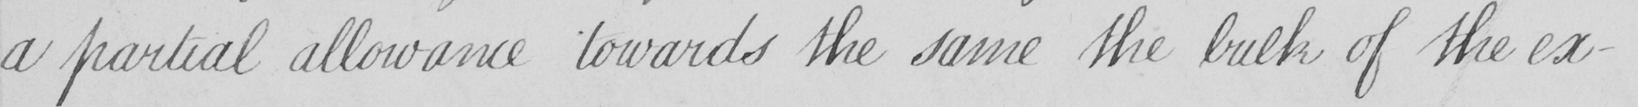Can you read and transcribe this handwriting? a partial allowance towards the same the bulk of the ex- 